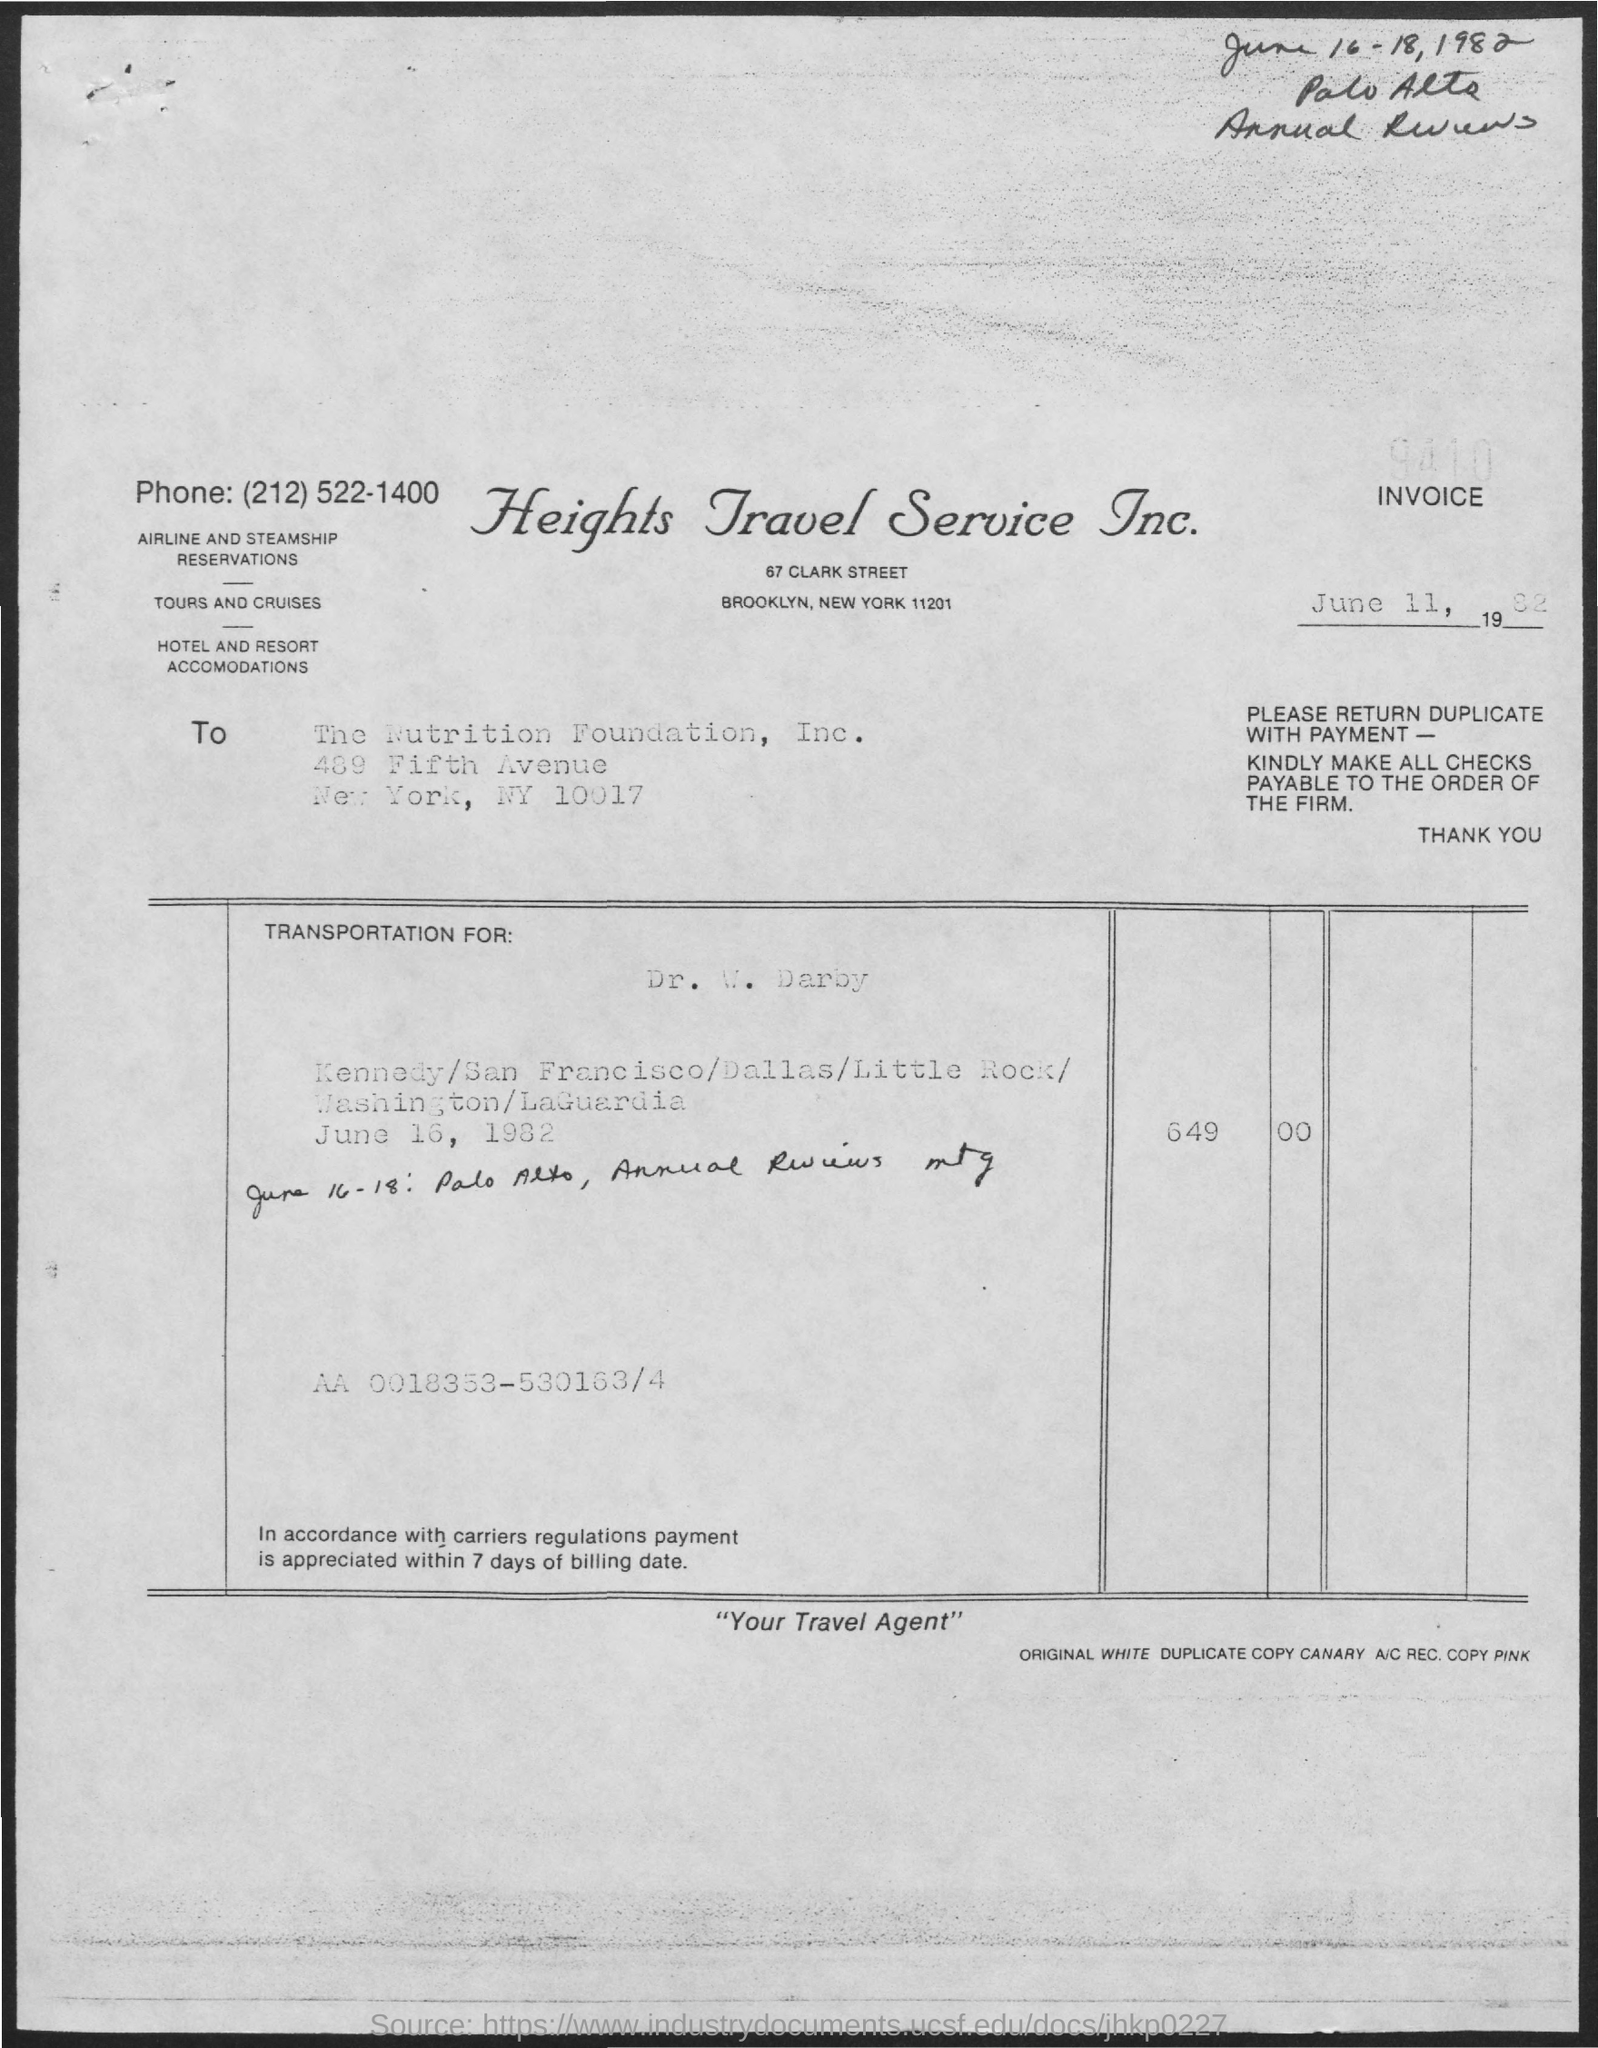Outline some significant characteristics in this image. The invoice is dated on June 11, 1982. 